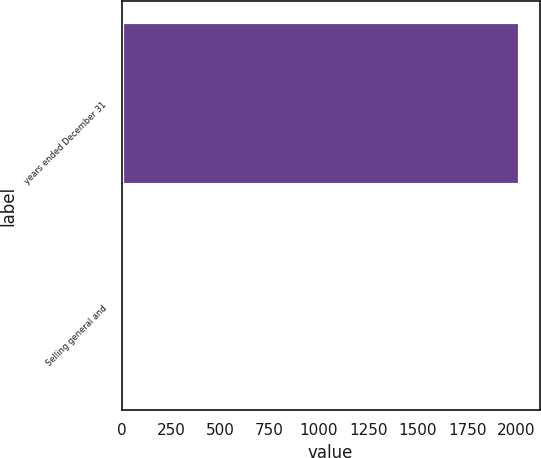<chart> <loc_0><loc_0><loc_500><loc_500><bar_chart><fcel>years ended December 31<fcel>Selling general and<nl><fcel>2017<fcel>7<nl></chart> 